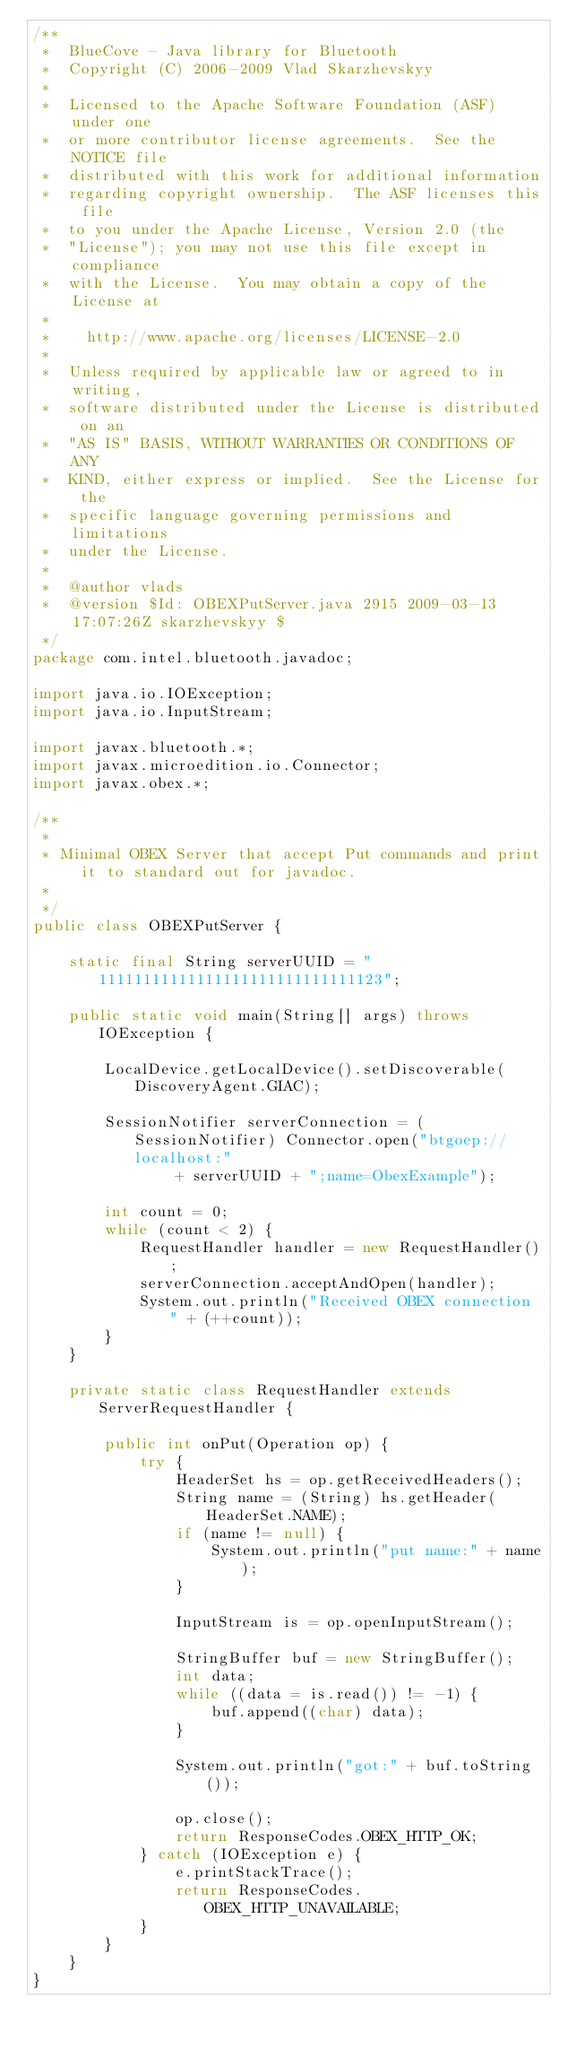<code> <loc_0><loc_0><loc_500><loc_500><_Java_>/**
 *  BlueCove - Java library for Bluetooth
 *  Copyright (C) 2006-2009 Vlad Skarzhevskyy
 *
 *  Licensed to the Apache Software Foundation (ASF) under one
 *  or more contributor license agreements.  See the NOTICE file
 *  distributed with this work for additional information
 *  regarding copyright ownership.  The ASF licenses this file
 *  to you under the Apache License, Version 2.0 (the
 *  "License"); you may not use this file except in compliance
 *  with the License.  You may obtain a copy of the License at
 *
 *    http://www.apache.org/licenses/LICENSE-2.0
 *
 *  Unless required by applicable law or agreed to in writing,
 *  software distributed under the License is distributed on an
 *  "AS IS" BASIS, WITHOUT WARRANTIES OR CONDITIONS OF ANY
 *  KIND, either express or implied.  See the License for the
 *  specific language governing permissions and limitations
 *  under the License.
 *
 *  @author vlads
 *  @version $Id: OBEXPutServer.java 2915 2009-03-13 17:07:26Z skarzhevskyy $
 */
package com.intel.bluetooth.javadoc;

import java.io.IOException;
import java.io.InputStream;

import javax.bluetooth.*;
import javax.microedition.io.Connector;
import javax.obex.*;

/**
 *
 * Minimal OBEX Server that accept Put commands and print it to standard out for javadoc.
 *
 */
public class OBEXPutServer {

    static final String serverUUID = "11111111111111111111111111111123";

    public static void main(String[] args) throws IOException {

        LocalDevice.getLocalDevice().setDiscoverable(DiscoveryAgent.GIAC);

        SessionNotifier serverConnection = (SessionNotifier) Connector.open("btgoep://localhost:"
                + serverUUID + ";name=ObexExample");

        int count = 0;
        while (count < 2) {
            RequestHandler handler = new RequestHandler();
            serverConnection.acceptAndOpen(handler);
            System.out.println("Received OBEX connection " + (++count));
        }
    }

    private static class RequestHandler extends ServerRequestHandler {

        public int onPut(Operation op) {
            try {
                HeaderSet hs = op.getReceivedHeaders();
                String name = (String) hs.getHeader(HeaderSet.NAME);
                if (name != null) {
                    System.out.println("put name:" + name);
                }

                InputStream is = op.openInputStream();

                StringBuffer buf = new StringBuffer();
                int data;
                while ((data = is.read()) != -1) {
                    buf.append((char) data);
                }

                System.out.println("got:" + buf.toString());

                op.close();
                return ResponseCodes.OBEX_HTTP_OK;
            } catch (IOException e) {
                e.printStackTrace();
                return ResponseCodes.OBEX_HTTP_UNAVAILABLE;
            }
        }
    }
}
</code> 